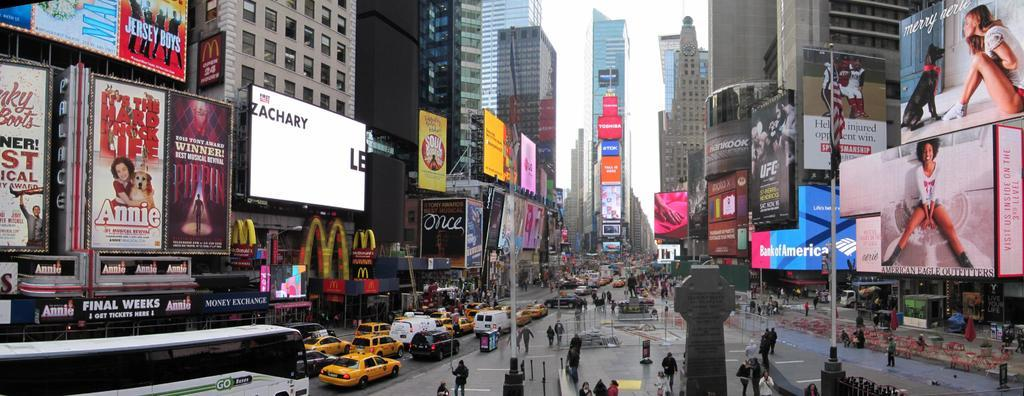<image>
Write a terse but informative summary of the picture. A busy street scene has billboards for shows like Annie and Jersey Boys. 